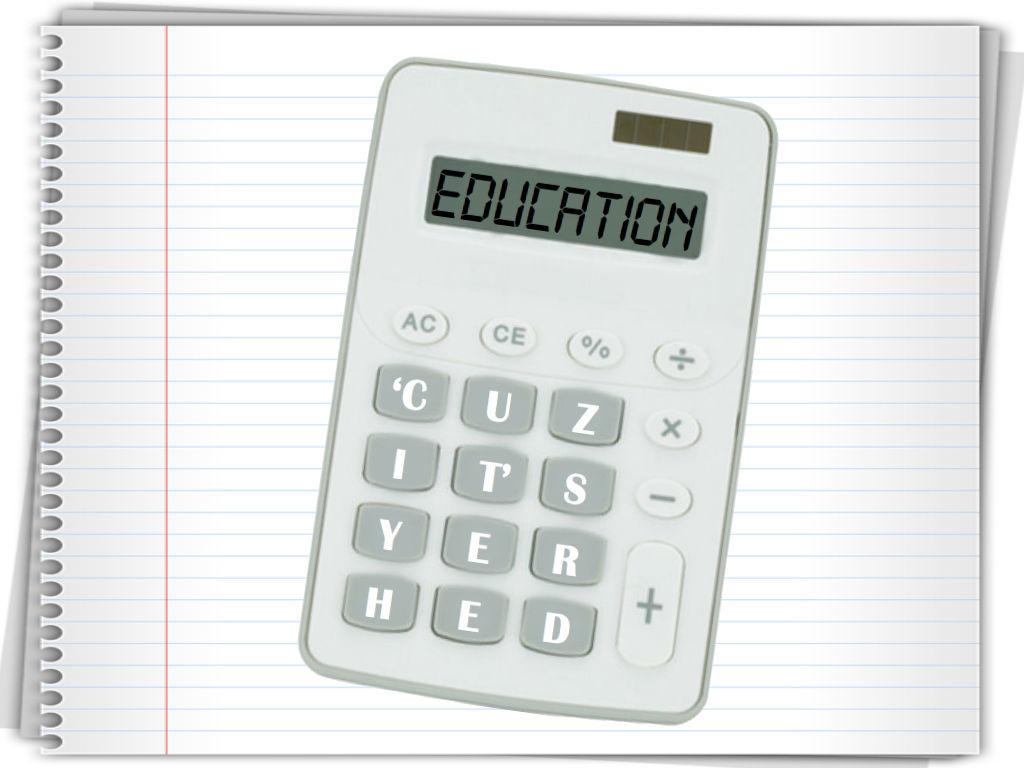<image>
Render a clear and concise summary of the photo. An advertisement showing a calculator with "Education, Cuz it's yer hed" on the screen and buttons on top of a notebook. 